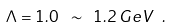<formula> <loc_0><loc_0><loc_500><loc_500>\Lambda = 1 . 0 \ \sim \ 1 . 2 \, G e V \ .</formula> 